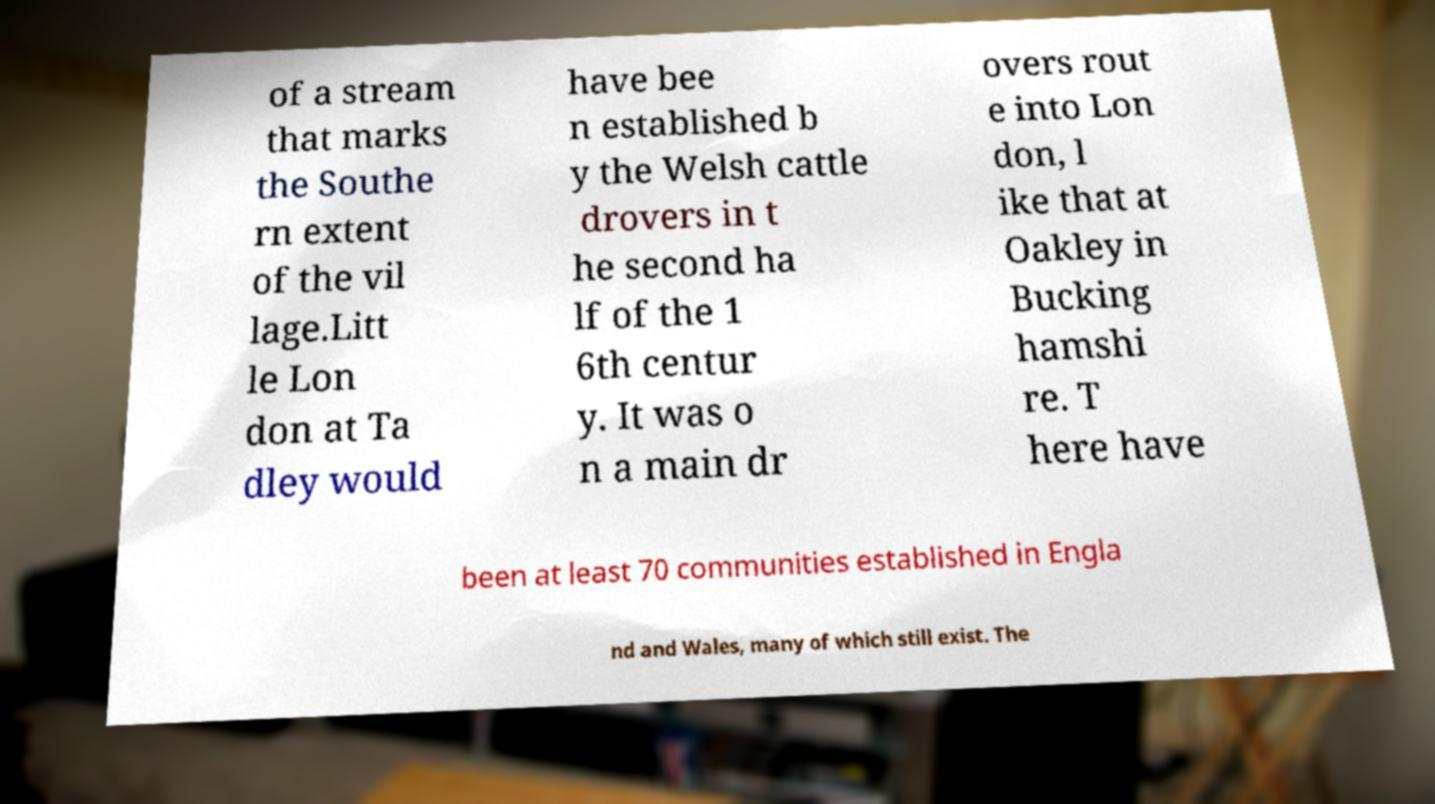I need the written content from this picture converted into text. Can you do that? of a stream that marks the Southe rn extent of the vil lage.Litt le Lon don at Ta dley would have bee n established b y the Welsh cattle drovers in t he second ha lf of the 1 6th centur y. It was o n a main dr overs rout e into Lon don, l ike that at Oakley in Bucking hamshi re. T here have been at least 70 communities established in Engla nd and Wales, many of which still exist. The 